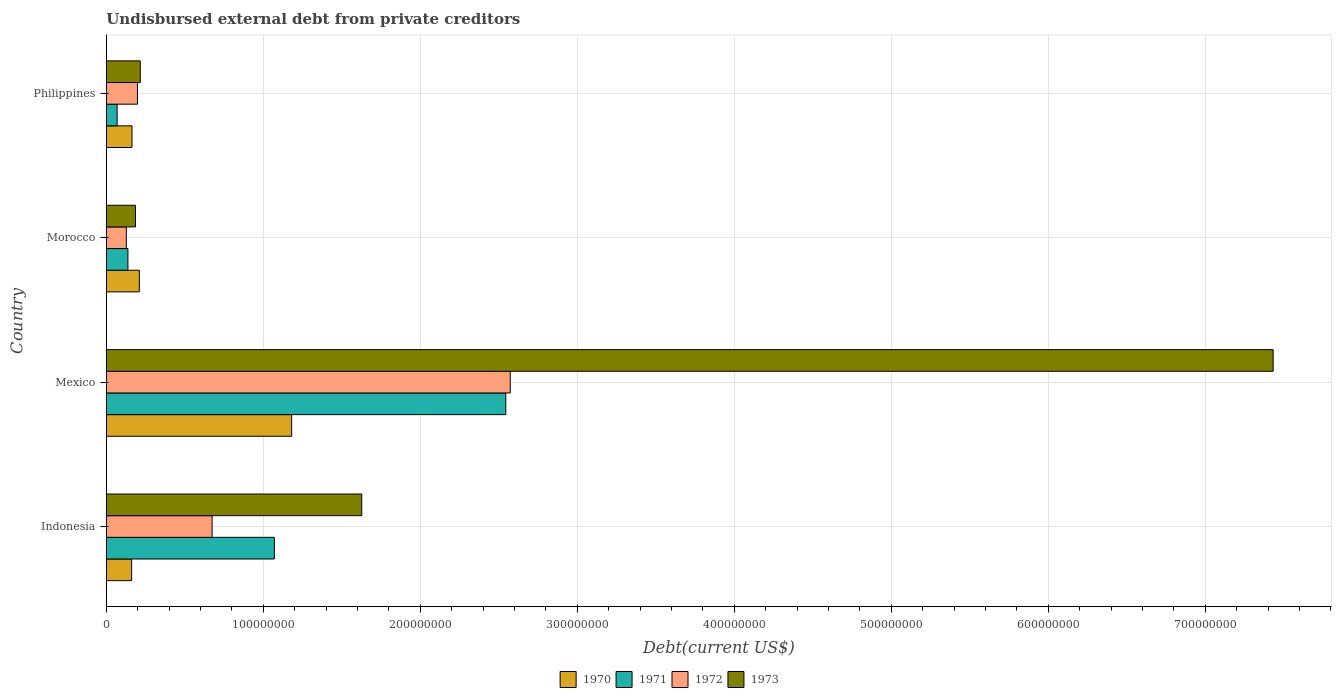How many different coloured bars are there?
Your answer should be compact. 4. How many groups of bars are there?
Offer a very short reply. 4. Are the number of bars per tick equal to the number of legend labels?
Keep it short and to the point. Yes. How many bars are there on the 2nd tick from the top?
Your answer should be very brief. 4. What is the total debt in 1970 in Philippines?
Keep it short and to the point. 1.64e+07. Across all countries, what is the maximum total debt in 1973?
Provide a succinct answer. 7.43e+08. Across all countries, what is the minimum total debt in 1972?
Provide a short and direct response. 1.27e+07. What is the total total debt in 1970 in the graph?
Offer a very short reply. 1.72e+08. What is the difference between the total debt in 1972 in Indonesia and that in Morocco?
Give a very brief answer. 5.46e+07. What is the difference between the total debt in 1971 in Mexico and the total debt in 1970 in Philippines?
Ensure brevity in your answer.  2.38e+08. What is the average total debt in 1971 per country?
Make the answer very short. 9.55e+07. What is the difference between the total debt in 1971 and total debt in 1970 in Philippines?
Provide a succinct answer. -9.48e+06. In how many countries, is the total debt in 1971 greater than 180000000 US$?
Keep it short and to the point. 1. What is the ratio of the total debt in 1970 in Indonesia to that in Morocco?
Make the answer very short. 0.77. Is the difference between the total debt in 1971 in Indonesia and Morocco greater than the difference between the total debt in 1970 in Indonesia and Morocco?
Make the answer very short. Yes. What is the difference between the highest and the second highest total debt in 1970?
Offer a very short reply. 9.70e+07. What is the difference between the highest and the lowest total debt in 1971?
Your answer should be compact. 2.48e+08. How many bars are there?
Provide a succinct answer. 16. What is the difference between two consecutive major ticks on the X-axis?
Your answer should be compact. 1.00e+08. Does the graph contain any zero values?
Your answer should be compact. No. Where does the legend appear in the graph?
Keep it short and to the point. Bottom center. How many legend labels are there?
Your answer should be compact. 4. How are the legend labels stacked?
Keep it short and to the point. Horizontal. What is the title of the graph?
Offer a very short reply. Undisbursed external debt from private creditors. What is the label or title of the X-axis?
Provide a short and direct response. Debt(current US$). What is the label or title of the Y-axis?
Offer a very short reply. Country. What is the Debt(current US$) in 1970 in Indonesia?
Your answer should be very brief. 1.61e+07. What is the Debt(current US$) of 1971 in Indonesia?
Your response must be concise. 1.07e+08. What is the Debt(current US$) of 1972 in Indonesia?
Make the answer very short. 6.74e+07. What is the Debt(current US$) in 1973 in Indonesia?
Your answer should be very brief. 1.63e+08. What is the Debt(current US$) in 1970 in Mexico?
Provide a short and direct response. 1.18e+08. What is the Debt(current US$) in 1971 in Mexico?
Your response must be concise. 2.54e+08. What is the Debt(current US$) in 1972 in Mexico?
Offer a very short reply. 2.57e+08. What is the Debt(current US$) in 1973 in Mexico?
Provide a succinct answer. 7.43e+08. What is the Debt(current US$) in 1970 in Morocco?
Offer a terse response. 2.10e+07. What is the Debt(current US$) of 1971 in Morocco?
Your response must be concise. 1.37e+07. What is the Debt(current US$) of 1972 in Morocco?
Provide a short and direct response. 1.27e+07. What is the Debt(current US$) of 1973 in Morocco?
Your answer should be compact. 1.86e+07. What is the Debt(current US$) in 1970 in Philippines?
Give a very brief answer. 1.64e+07. What is the Debt(current US$) of 1971 in Philippines?
Ensure brevity in your answer.  6.87e+06. What is the Debt(current US$) of 1972 in Philippines?
Make the answer very short. 1.99e+07. What is the Debt(current US$) in 1973 in Philippines?
Provide a succinct answer. 2.16e+07. Across all countries, what is the maximum Debt(current US$) of 1970?
Your response must be concise. 1.18e+08. Across all countries, what is the maximum Debt(current US$) in 1971?
Offer a terse response. 2.54e+08. Across all countries, what is the maximum Debt(current US$) of 1972?
Make the answer very short. 2.57e+08. Across all countries, what is the maximum Debt(current US$) of 1973?
Your answer should be compact. 7.43e+08. Across all countries, what is the minimum Debt(current US$) in 1970?
Your response must be concise. 1.61e+07. Across all countries, what is the minimum Debt(current US$) of 1971?
Provide a short and direct response. 6.87e+06. Across all countries, what is the minimum Debt(current US$) of 1972?
Provide a succinct answer. 1.27e+07. Across all countries, what is the minimum Debt(current US$) in 1973?
Your answer should be very brief. 1.86e+07. What is the total Debt(current US$) in 1970 in the graph?
Provide a succinct answer. 1.72e+08. What is the total Debt(current US$) of 1971 in the graph?
Offer a terse response. 3.82e+08. What is the total Debt(current US$) of 1972 in the graph?
Give a very brief answer. 3.57e+08. What is the total Debt(current US$) in 1973 in the graph?
Offer a terse response. 9.46e+08. What is the difference between the Debt(current US$) of 1970 in Indonesia and that in Mexico?
Your answer should be very brief. -1.02e+08. What is the difference between the Debt(current US$) of 1971 in Indonesia and that in Mexico?
Provide a short and direct response. -1.47e+08. What is the difference between the Debt(current US$) of 1972 in Indonesia and that in Mexico?
Ensure brevity in your answer.  -1.90e+08. What is the difference between the Debt(current US$) of 1973 in Indonesia and that in Mexico?
Ensure brevity in your answer.  -5.81e+08. What is the difference between the Debt(current US$) of 1970 in Indonesia and that in Morocco?
Your answer should be compact. -4.89e+06. What is the difference between the Debt(current US$) in 1971 in Indonesia and that in Morocco?
Provide a short and direct response. 9.33e+07. What is the difference between the Debt(current US$) of 1972 in Indonesia and that in Morocco?
Ensure brevity in your answer.  5.46e+07. What is the difference between the Debt(current US$) in 1973 in Indonesia and that in Morocco?
Make the answer very short. 1.44e+08. What is the difference between the Debt(current US$) in 1970 in Indonesia and that in Philippines?
Offer a very short reply. -2.28e+05. What is the difference between the Debt(current US$) in 1971 in Indonesia and that in Philippines?
Your response must be concise. 1.00e+08. What is the difference between the Debt(current US$) of 1972 in Indonesia and that in Philippines?
Offer a terse response. 4.75e+07. What is the difference between the Debt(current US$) in 1973 in Indonesia and that in Philippines?
Your answer should be compact. 1.41e+08. What is the difference between the Debt(current US$) in 1970 in Mexico and that in Morocco?
Make the answer very short. 9.70e+07. What is the difference between the Debt(current US$) of 1971 in Mexico and that in Morocco?
Your answer should be very brief. 2.41e+08. What is the difference between the Debt(current US$) in 1972 in Mexico and that in Morocco?
Offer a very short reply. 2.45e+08. What is the difference between the Debt(current US$) of 1973 in Mexico and that in Morocco?
Offer a terse response. 7.25e+08. What is the difference between the Debt(current US$) in 1970 in Mexico and that in Philippines?
Your answer should be compact. 1.02e+08. What is the difference between the Debt(current US$) in 1971 in Mexico and that in Philippines?
Provide a succinct answer. 2.48e+08. What is the difference between the Debt(current US$) of 1972 in Mexico and that in Philippines?
Make the answer very short. 2.37e+08. What is the difference between the Debt(current US$) of 1973 in Mexico and that in Philippines?
Your answer should be compact. 7.22e+08. What is the difference between the Debt(current US$) of 1970 in Morocco and that in Philippines?
Ensure brevity in your answer.  4.66e+06. What is the difference between the Debt(current US$) in 1971 in Morocco and that in Philippines?
Your response must be concise. 6.88e+06. What is the difference between the Debt(current US$) in 1972 in Morocco and that in Philippines?
Your response must be concise. -7.12e+06. What is the difference between the Debt(current US$) of 1973 in Morocco and that in Philippines?
Make the answer very short. -3.06e+06. What is the difference between the Debt(current US$) in 1970 in Indonesia and the Debt(current US$) in 1971 in Mexico?
Your response must be concise. -2.38e+08. What is the difference between the Debt(current US$) in 1970 in Indonesia and the Debt(current US$) in 1972 in Mexico?
Ensure brevity in your answer.  -2.41e+08. What is the difference between the Debt(current US$) of 1970 in Indonesia and the Debt(current US$) of 1973 in Mexico?
Offer a very short reply. -7.27e+08. What is the difference between the Debt(current US$) of 1971 in Indonesia and the Debt(current US$) of 1972 in Mexico?
Offer a very short reply. -1.50e+08. What is the difference between the Debt(current US$) of 1971 in Indonesia and the Debt(current US$) of 1973 in Mexico?
Your answer should be very brief. -6.36e+08. What is the difference between the Debt(current US$) in 1972 in Indonesia and the Debt(current US$) in 1973 in Mexico?
Provide a succinct answer. -6.76e+08. What is the difference between the Debt(current US$) in 1970 in Indonesia and the Debt(current US$) in 1971 in Morocco?
Offer a terse response. 2.38e+06. What is the difference between the Debt(current US$) of 1970 in Indonesia and the Debt(current US$) of 1972 in Morocco?
Give a very brief answer. 3.39e+06. What is the difference between the Debt(current US$) of 1970 in Indonesia and the Debt(current US$) of 1973 in Morocco?
Make the answer very short. -2.44e+06. What is the difference between the Debt(current US$) of 1971 in Indonesia and the Debt(current US$) of 1972 in Morocco?
Provide a short and direct response. 9.43e+07. What is the difference between the Debt(current US$) of 1971 in Indonesia and the Debt(current US$) of 1973 in Morocco?
Keep it short and to the point. 8.85e+07. What is the difference between the Debt(current US$) of 1972 in Indonesia and the Debt(current US$) of 1973 in Morocco?
Offer a terse response. 4.88e+07. What is the difference between the Debt(current US$) of 1970 in Indonesia and the Debt(current US$) of 1971 in Philippines?
Provide a short and direct response. 9.25e+06. What is the difference between the Debt(current US$) of 1970 in Indonesia and the Debt(current US$) of 1972 in Philippines?
Make the answer very short. -3.73e+06. What is the difference between the Debt(current US$) of 1970 in Indonesia and the Debt(current US$) of 1973 in Philippines?
Provide a succinct answer. -5.49e+06. What is the difference between the Debt(current US$) of 1971 in Indonesia and the Debt(current US$) of 1972 in Philippines?
Provide a succinct answer. 8.72e+07. What is the difference between the Debt(current US$) of 1971 in Indonesia and the Debt(current US$) of 1973 in Philippines?
Your answer should be very brief. 8.54e+07. What is the difference between the Debt(current US$) in 1972 in Indonesia and the Debt(current US$) in 1973 in Philippines?
Offer a very short reply. 4.58e+07. What is the difference between the Debt(current US$) of 1970 in Mexico and the Debt(current US$) of 1971 in Morocco?
Provide a succinct answer. 1.04e+08. What is the difference between the Debt(current US$) in 1970 in Mexico and the Debt(current US$) in 1972 in Morocco?
Offer a terse response. 1.05e+08. What is the difference between the Debt(current US$) of 1970 in Mexico and the Debt(current US$) of 1973 in Morocco?
Offer a very short reply. 9.95e+07. What is the difference between the Debt(current US$) in 1971 in Mexico and the Debt(current US$) in 1972 in Morocco?
Offer a terse response. 2.42e+08. What is the difference between the Debt(current US$) of 1971 in Mexico and the Debt(current US$) of 1973 in Morocco?
Provide a succinct answer. 2.36e+08. What is the difference between the Debt(current US$) in 1972 in Mexico and the Debt(current US$) in 1973 in Morocco?
Your response must be concise. 2.39e+08. What is the difference between the Debt(current US$) in 1970 in Mexico and the Debt(current US$) in 1971 in Philippines?
Make the answer very short. 1.11e+08. What is the difference between the Debt(current US$) in 1970 in Mexico and the Debt(current US$) in 1972 in Philippines?
Your answer should be compact. 9.82e+07. What is the difference between the Debt(current US$) in 1970 in Mexico and the Debt(current US$) in 1973 in Philippines?
Provide a short and direct response. 9.64e+07. What is the difference between the Debt(current US$) in 1971 in Mexico and the Debt(current US$) in 1972 in Philippines?
Your response must be concise. 2.35e+08. What is the difference between the Debt(current US$) of 1971 in Mexico and the Debt(current US$) of 1973 in Philippines?
Provide a short and direct response. 2.33e+08. What is the difference between the Debt(current US$) in 1972 in Mexico and the Debt(current US$) in 1973 in Philippines?
Make the answer very short. 2.36e+08. What is the difference between the Debt(current US$) of 1970 in Morocco and the Debt(current US$) of 1971 in Philippines?
Your answer should be very brief. 1.41e+07. What is the difference between the Debt(current US$) in 1970 in Morocco and the Debt(current US$) in 1972 in Philippines?
Provide a succinct answer. 1.16e+06. What is the difference between the Debt(current US$) of 1970 in Morocco and the Debt(current US$) of 1973 in Philippines?
Your response must be concise. -6.03e+05. What is the difference between the Debt(current US$) in 1971 in Morocco and the Debt(current US$) in 1972 in Philippines?
Make the answer very short. -6.10e+06. What is the difference between the Debt(current US$) of 1971 in Morocco and the Debt(current US$) of 1973 in Philippines?
Your answer should be compact. -7.87e+06. What is the difference between the Debt(current US$) in 1972 in Morocco and the Debt(current US$) in 1973 in Philippines?
Offer a very short reply. -8.88e+06. What is the average Debt(current US$) in 1970 per country?
Give a very brief answer. 4.29e+07. What is the average Debt(current US$) of 1971 per country?
Offer a very short reply. 9.55e+07. What is the average Debt(current US$) in 1972 per country?
Offer a very short reply. 8.93e+07. What is the average Debt(current US$) of 1973 per country?
Your response must be concise. 2.37e+08. What is the difference between the Debt(current US$) of 1970 and Debt(current US$) of 1971 in Indonesia?
Provide a succinct answer. -9.09e+07. What is the difference between the Debt(current US$) of 1970 and Debt(current US$) of 1972 in Indonesia?
Your response must be concise. -5.12e+07. What is the difference between the Debt(current US$) of 1970 and Debt(current US$) of 1973 in Indonesia?
Give a very brief answer. -1.47e+08. What is the difference between the Debt(current US$) in 1971 and Debt(current US$) in 1972 in Indonesia?
Your response must be concise. 3.96e+07. What is the difference between the Debt(current US$) in 1971 and Debt(current US$) in 1973 in Indonesia?
Your response must be concise. -5.57e+07. What is the difference between the Debt(current US$) of 1972 and Debt(current US$) of 1973 in Indonesia?
Ensure brevity in your answer.  -9.53e+07. What is the difference between the Debt(current US$) in 1970 and Debt(current US$) in 1971 in Mexico?
Give a very brief answer. -1.36e+08. What is the difference between the Debt(current US$) of 1970 and Debt(current US$) of 1972 in Mexico?
Offer a very short reply. -1.39e+08. What is the difference between the Debt(current US$) of 1970 and Debt(current US$) of 1973 in Mexico?
Your answer should be compact. -6.25e+08. What is the difference between the Debt(current US$) in 1971 and Debt(current US$) in 1972 in Mexico?
Your answer should be compact. -2.84e+06. What is the difference between the Debt(current US$) of 1971 and Debt(current US$) of 1973 in Mexico?
Your response must be concise. -4.89e+08. What is the difference between the Debt(current US$) of 1972 and Debt(current US$) of 1973 in Mexico?
Your answer should be very brief. -4.86e+08. What is the difference between the Debt(current US$) of 1970 and Debt(current US$) of 1971 in Morocco?
Your response must be concise. 7.27e+06. What is the difference between the Debt(current US$) in 1970 and Debt(current US$) in 1972 in Morocco?
Your answer should be compact. 8.28e+06. What is the difference between the Debt(current US$) of 1970 and Debt(current US$) of 1973 in Morocco?
Offer a very short reply. 2.45e+06. What is the difference between the Debt(current US$) in 1971 and Debt(current US$) in 1972 in Morocco?
Provide a succinct answer. 1.01e+06. What is the difference between the Debt(current US$) of 1971 and Debt(current US$) of 1973 in Morocco?
Provide a succinct answer. -4.81e+06. What is the difference between the Debt(current US$) in 1972 and Debt(current US$) in 1973 in Morocco?
Keep it short and to the point. -5.82e+06. What is the difference between the Debt(current US$) in 1970 and Debt(current US$) in 1971 in Philippines?
Offer a terse response. 9.48e+06. What is the difference between the Debt(current US$) of 1970 and Debt(current US$) of 1972 in Philippines?
Your answer should be very brief. -3.50e+06. What is the difference between the Debt(current US$) of 1970 and Debt(current US$) of 1973 in Philippines?
Provide a short and direct response. -5.27e+06. What is the difference between the Debt(current US$) of 1971 and Debt(current US$) of 1972 in Philippines?
Your answer should be very brief. -1.30e+07. What is the difference between the Debt(current US$) in 1971 and Debt(current US$) in 1973 in Philippines?
Offer a terse response. -1.47e+07. What is the difference between the Debt(current US$) in 1972 and Debt(current US$) in 1973 in Philippines?
Provide a short and direct response. -1.76e+06. What is the ratio of the Debt(current US$) in 1970 in Indonesia to that in Mexico?
Your answer should be very brief. 0.14. What is the ratio of the Debt(current US$) in 1971 in Indonesia to that in Mexico?
Keep it short and to the point. 0.42. What is the ratio of the Debt(current US$) in 1972 in Indonesia to that in Mexico?
Give a very brief answer. 0.26. What is the ratio of the Debt(current US$) in 1973 in Indonesia to that in Mexico?
Ensure brevity in your answer.  0.22. What is the ratio of the Debt(current US$) of 1970 in Indonesia to that in Morocco?
Provide a short and direct response. 0.77. What is the ratio of the Debt(current US$) of 1971 in Indonesia to that in Morocco?
Give a very brief answer. 7.78. What is the ratio of the Debt(current US$) in 1972 in Indonesia to that in Morocco?
Keep it short and to the point. 5.29. What is the ratio of the Debt(current US$) in 1973 in Indonesia to that in Morocco?
Keep it short and to the point. 8.77. What is the ratio of the Debt(current US$) of 1970 in Indonesia to that in Philippines?
Give a very brief answer. 0.99. What is the ratio of the Debt(current US$) of 1971 in Indonesia to that in Philippines?
Make the answer very short. 15.57. What is the ratio of the Debt(current US$) of 1972 in Indonesia to that in Philippines?
Ensure brevity in your answer.  3.39. What is the ratio of the Debt(current US$) in 1973 in Indonesia to that in Philippines?
Your response must be concise. 7.53. What is the ratio of the Debt(current US$) of 1970 in Mexico to that in Morocco?
Keep it short and to the point. 5.62. What is the ratio of the Debt(current US$) in 1971 in Mexico to that in Morocco?
Provide a succinct answer. 18.51. What is the ratio of the Debt(current US$) in 1972 in Mexico to that in Morocco?
Keep it short and to the point. 20.2. What is the ratio of the Debt(current US$) of 1973 in Mexico to that in Morocco?
Provide a succinct answer. 40.04. What is the ratio of the Debt(current US$) in 1970 in Mexico to that in Philippines?
Your response must be concise. 7.22. What is the ratio of the Debt(current US$) of 1971 in Mexico to that in Philippines?
Your answer should be very brief. 37.02. What is the ratio of the Debt(current US$) in 1972 in Mexico to that in Philippines?
Provide a short and direct response. 12.96. What is the ratio of the Debt(current US$) in 1973 in Mexico to that in Philippines?
Your answer should be very brief. 34.38. What is the ratio of the Debt(current US$) in 1970 in Morocco to that in Philippines?
Provide a succinct answer. 1.29. What is the ratio of the Debt(current US$) of 1971 in Morocco to that in Philippines?
Ensure brevity in your answer.  2. What is the ratio of the Debt(current US$) of 1972 in Morocco to that in Philippines?
Keep it short and to the point. 0.64. What is the ratio of the Debt(current US$) in 1973 in Morocco to that in Philippines?
Keep it short and to the point. 0.86. What is the difference between the highest and the second highest Debt(current US$) in 1970?
Provide a succinct answer. 9.70e+07. What is the difference between the highest and the second highest Debt(current US$) in 1971?
Your response must be concise. 1.47e+08. What is the difference between the highest and the second highest Debt(current US$) of 1972?
Offer a terse response. 1.90e+08. What is the difference between the highest and the second highest Debt(current US$) of 1973?
Give a very brief answer. 5.81e+08. What is the difference between the highest and the lowest Debt(current US$) of 1970?
Keep it short and to the point. 1.02e+08. What is the difference between the highest and the lowest Debt(current US$) of 1971?
Provide a short and direct response. 2.48e+08. What is the difference between the highest and the lowest Debt(current US$) of 1972?
Offer a terse response. 2.45e+08. What is the difference between the highest and the lowest Debt(current US$) of 1973?
Your response must be concise. 7.25e+08. 